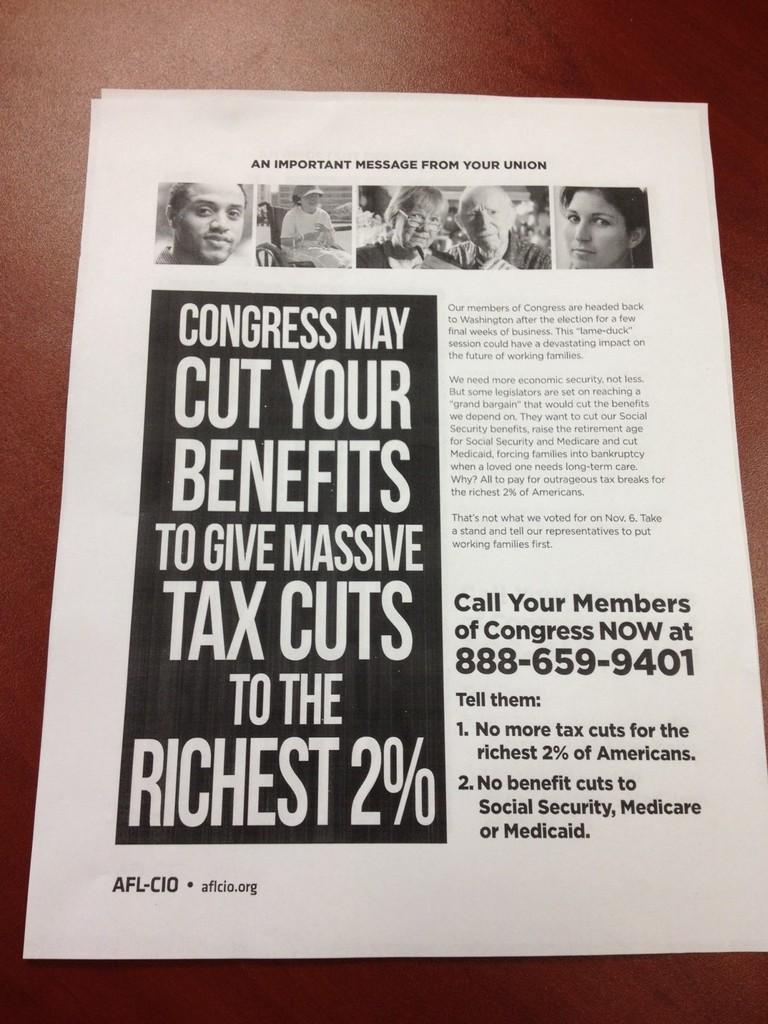Provide a one-sentence caption for the provided image. A black and white page with the heading of "An Important Message from your Union" sits on a table. 